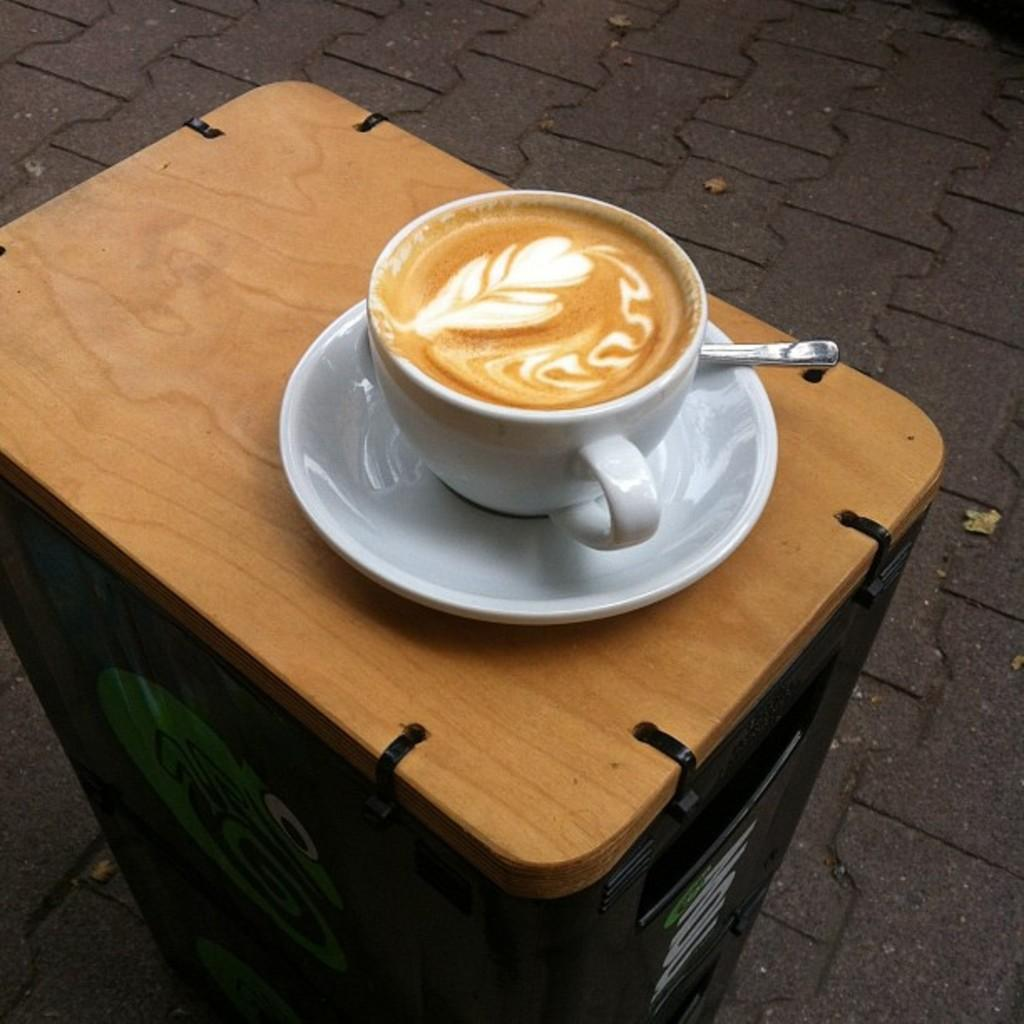What is the main feature of the image? There is a road in the image. What objects can be seen on the table in the image? There is a cup, a saucer, and a spoon on the table in the image. What type of advice does the lawyer give to the uncle in the image? There is no lawyer or uncle present in the image, so it is not possible to answer that question. 